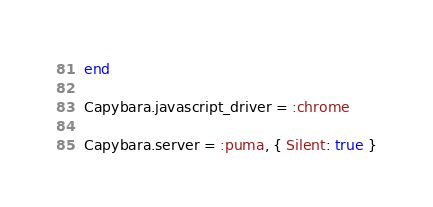<code> <loc_0><loc_0><loc_500><loc_500><_Ruby_>end

Capybara.javascript_driver = :chrome

Capybara.server = :puma, { Silent: true }
</code> 